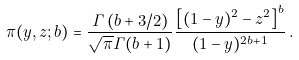Convert formula to latex. <formula><loc_0><loc_0><loc_500><loc_500>\pi ( y , z ; b ) = \frac { { \mathit \Gamma } \left ( b + 3 / 2 \right ) } { \sqrt { \pi } { \mathit \Gamma } ( b + 1 ) } \frac { \left [ ( 1 - y ) ^ { 2 } - z ^ { 2 } \right ] ^ { b } } { ( 1 - y ) ^ { 2 b + 1 } } \, .</formula> 